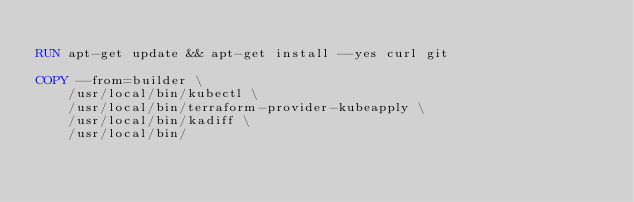<code> <loc_0><loc_0><loc_500><loc_500><_Dockerfile_>
RUN apt-get update && apt-get install --yes curl git

COPY --from=builder \
    /usr/local/bin/kubectl \
    /usr/local/bin/terraform-provider-kubeapply \
    /usr/local/bin/kadiff \
    /usr/local/bin/
</code> 